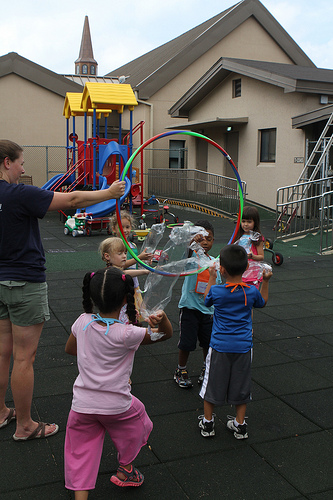<image>
Is the jungle gym above the girl? No. The jungle gym is not positioned above the girl. The vertical arrangement shows a different relationship. 